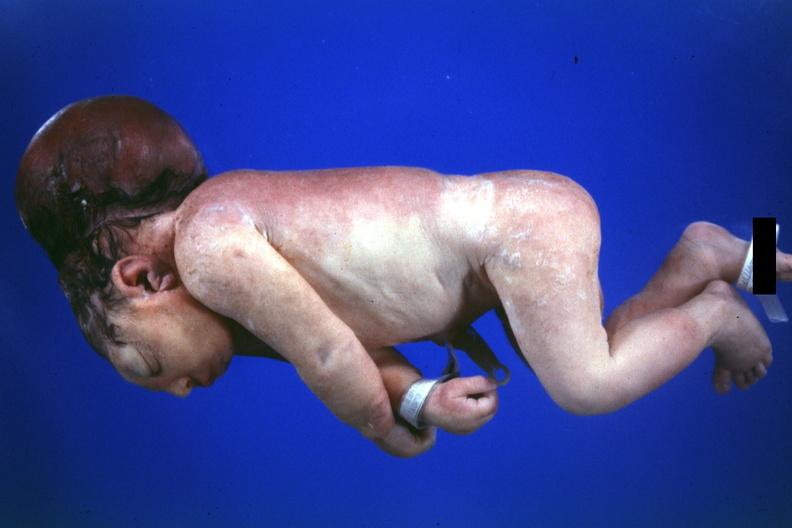does this image show dysraphism encephalocele occipital premature female no chromosomal defects lived one day?
Answer the question using a single word or phrase. Yes 